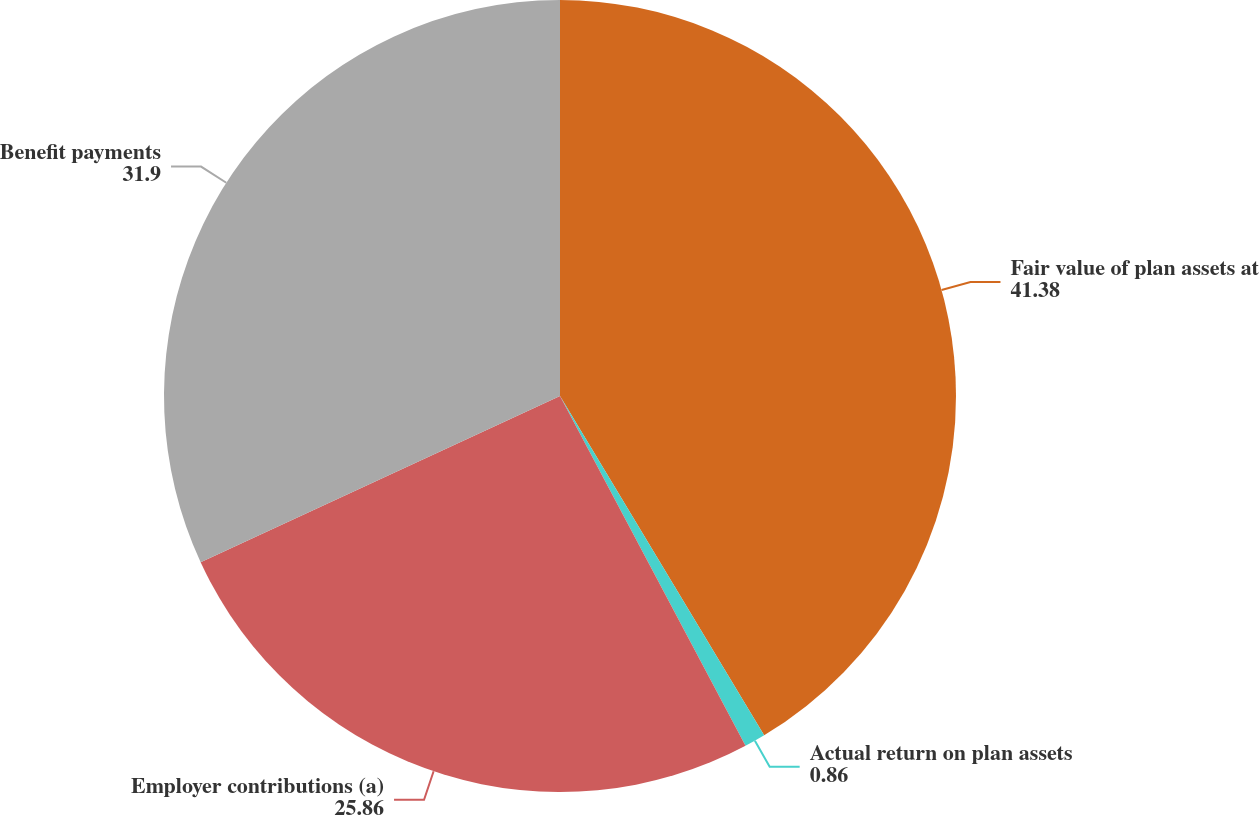<chart> <loc_0><loc_0><loc_500><loc_500><pie_chart><fcel>Fair value of plan assets at<fcel>Actual return on plan assets<fcel>Employer contributions (a)<fcel>Benefit payments<nl><fcel>41.38%<fcel>0.86%<fcel>25.86%<fcel>31.9%<nl></chart> 